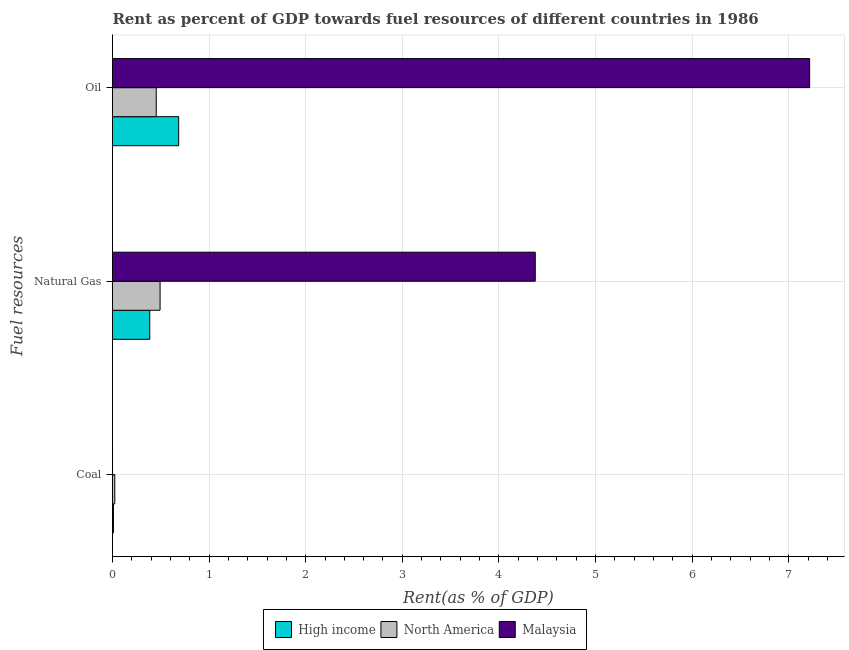How many different coloured bars are there?
Offer a terse response. 3. What is the label of the 1st group of bars from the top?
Offer a terse response. Oil. What is the rent towards oil in High income?
Offer a terse response. 0.68. Across all countries, what is the maximum rent towards natural gas?
Provide a succinct answer. 4.38. Across all countries, what is the minimum rent towards natural gas?
Make the answer very short. 0.39. In which country was the rent towards oil maximum?
Make the answer very short. Malaysia. In which country was the rent towards coal minimum?
Provide a succinct answer. Malaysia. What is the total rent towards natural gas in the graph?
Your answer should be very brief. 5.25. What is the difference between the rent towards natural gas in North America and that in Malaysia?
Ensure brevity in your answer.  -3.88. What is the difference between the rent towards coal in Malaysia and the rent towards oil in High income?
Provide a short and direct response. -0.68. What is the average rent towards coal per country?
Give a very brief answer. 0.01. What is the difference between the rent towards natural gas and rent towards coal in Malaysia?
Make the answer very short. 4.38. What is the ratio of the rent towards oil in High income to that in Malaysia?
Your response must be concise. 0.09. Is the difference between the rent towards coal in North America and High income greater than the difference between the rent towards oil in North America and High income?
Provide a short and direct response. Yes. What is the difference between the highest and the second highest rent towards oil?
Give a very brief answer. 6.53. What is the difference between the highest and the lowest rent towards natural gas?
Your response must be concise. 3.99. In how many countries, is the rent towards natural gas greater than the average rent towards natural gas taken over all countries?
Offer a very short reply. 1. Is the sum of the rent towards coal in Malaysia and High income greater than the maximum rent towards oil across all countries?
Provide a succinct answer. No. What does the 1st bar from the top in Oil represents?
Give a very brief answer. Malaysia. Is it the case that in every country, the sum of the rent towards coal and rent towards natural gas is greater than the rent towards oil?
Give a very brief answer. No. Are all the bars in the graph horizontal?
Provide a succinct answer. Yes. Are the values on the major ticks of X-axis written in scientific E-notation?
Ensure brevity in your answer.  No. Does the graph contain any zero values?
Your answer should be compact. No. Does the graph contain grids?
Keep it short and to the point. Yes. Where does the legend appear in the graph?
Make the answer very short. Bottom center. What is the title of the graph?
Offer a terse response. Rent as percent of GDP towards fuel resources of different countries in 1986. What is the label or title of the X-axis?
Provide a succinct answer. Rent(as % of GDP). What is the label or title of the Y-axis?
Provide a short and direct response. Fuel resources. What is the Rent(as % of GDP) of High income in Coal?
Give a very brief answer. 0.01. What is the Rent(as % of GDP) of North America in Coal?
Your answer should be very brief. 0.02. What is the Rent(as % of GDP) in Malaysia in Coal?
Provide a succinct answer. 0. What is the Rent(as % of GDP) of High income in Natural Gas?
Make the answer very short. 0.39. What is the Rent(as % of GDP) in North America in Natural Gas?
Keep it short and to the point. 0.49. What is the Rent(as % of GDP) in Malaysia in Natural Gas?
Your response must be concise. 4.38. What is the Rent(as % of GDP) in High income in Oil?
Give a very brief answer. 0.68. What is the Rent(as % of GDP) in North America in Oil?
Provide a short and direct response. 0.45. What is the Rent(as % of GDP) in Malaysia in Oil?
Offer a terse response. 7.22. Across all Fuel resources, what is the maximum Rent(as % of GDP) of High income?
Your response must be concise. 0.68. Across all Fuel resources, what is the maximum Rent(as % of GDP) of North America?
Ensure brevity in your answer.  0.49. Across all Fuel resources, what is the maximum Rent(as % of GDP) in Malaysia?
Make the answer very short. 7.22. Across all Fuel resources, what is the minimum Rent(as % of GDP) in High income?
Give a very brief answer. 0.01. Across all Fuel resources, what is the minimum Rent(as % of GDP) of North America?
Keep it short and to the point. 0.02. Across all Fuel resources, what is the minimum Rent(as % of GDP) of Malaysia?
Offer a very short reply. 0. What is the total Rent(as % of GDP) in High income in the graph?
Give a very brief answer. 1.08. What is the total Rent(as % of GDP) of North America in the graph?
Your answer should be very brief. 0.97. What is the total Rent(as % of GDP) in Malaysia in the graph?
Ensure brevity in your answer.  11.59. What is the difference between the Rent(as % of GDP) of High income in Coal and that in Natural Gas?
Offer a terse response. -0.38. What is the difference between the Rent(as % of GDP) of North America in Coal and that in Natural Gas?
Your answer should be very brief. -0.47. What is the difference between the Rent(as % of GDP) of Malaysia in Coal and that in Natural Gas?
Your answer should be very brief. -4.38. What is the difference between the Rent(as % of GDP) in High income in Coal and that in Oil?
Ensure brevity in your answer.  -0.68. What is the difference between the Rent(as % of GDP) of North America in Coal and that in Oil?
Ensure brevity in your answer.  -0.43. What is the difference between the Rent(as % of GDP) in Malaysia in Coal and that in Oil?
Offer a terse response. -7.22. What is the difference between the Rent(as % of GDP) in High income in Natural Gas and that in Oil?
Keep it short and to the point. -0.3. What is the difference between the Rent(as % of GDP) of North America in Natural Gas and that in Oil?
Provide a short and direct response. 0.04. What is the difference between the Rent(as % of GDP) of Malaysia in Natural Gas and that in Oil?
Make the answer very short. -2.84. What is the difference between the Rent(as % of GDP) in High income in Coal and the Rent(as % of GDP) in North America in Natural Gas?
Provide a short and direct response. -0.48. What is the difference between the Rent(as % of GDP) of High income in Coal and the Rent(as % of GDP) of Malaysia in Natural Gas?
Offer a very short reply. -4.37. What is the difference between the Rent(as % of GDP) in North America in Coal and the Rent(as % of GDP) in Malaysia in Natural Gas?
Your answer should be very brief. -4.35. What is the difference between the Rent(as % of GDP) of High income in Coal and the Rent(as % of GDP) of North America in Oil?
Your answer should be very brief. -0.44. What is the difference between the Rent(as % of GDP) of High income in Coal and the Rent(as % of GDP) of Malaysia in Oil?
Your answer should be compact. -7.21. What is the difference between the Rent(as % of GDP) of North America in Coal and the Rent(as % of GDP) of Malaysia in Oil?
Provide a short and direct response. -7.19. What is the difference between the Rent(as % of GDP) in High income in Natural Gas and the Rent(as % of GDP) in North America in Oil?
Provide a succinct answer. -0.07. What is the difference between the Rent(as % of GDP) in High income in Natural Gas and the Rent(as % of GDP) in Malaysia in Oil?
Your answer should be very brief. -6.83. What is the difference between the Rent(as % of GDP) in North America in Natural Gas and the Rent(as % of GDP) in Malaysia in Oil?
Provide a short and direct response. -6.72. What is the average Rent(as % of GDP) in High income per Fuel resources?
Your answer should be very brief. 0.36. What is the average Rent(as % of GDP) in North America per Fuel resources?
Your answer should be very brief. 0.32. What is the average Rent(as % of GDP) in Malaysia per Fuel resources?
Keep it short and to the point. 3.86. What is the difference between the Rent(as % of GDP) of High income and Rent(as % of GDP) of North America in Coal?
Offer a very short reply. -0.01. What is the difference between the Rent(as % of GDP) of High income and Rent(as % of GDP) of Malaysia in Coal?
Keep it short and to the point. 0.01. What is the difference between the Rent(as % of GDP) in North America and Rent(as % of GDP) in Malaysia in Coal?
Ensure brevity in your answer.  0.02. What is the difference between the Rent(as % of GDP) in High income and Rent(as % of GDP) in North America in Natural Gas?
Offer a very short reply. -0.11. What is the difference between the Rent(as % of GDP) in High income and Rent(as % of GDP) in Malaysia in Natural Gas?
Provide a succinct answer. -3.99. What is the difference between the Rent(as % of GDP) of North America and Rent(as % of GDP) of Malaysia in Natural Gas?
Provide a succinct answer. -3.88. What is the difference between the Rent(as % of GDP) of High income and Rent(as % of GDP) of North America in Oil?
Your answer should be very brief. 0.23. What is the difference between the Rent(as % of GDP) in High income and Rent(as % of GDP) in Malaysia in Oil?
Make the answer very short. -6.53. What is the difference between the Rent(as % of GDP) in North America and Rent(as % of GDP) in Malaysia in Oil?
Your answer should be compact. -6.76. What is the ratio of the Rent(as % of GDP) of High income in Coal to that in Natural Gas?
Make the answer very short. 0.03. What is the ratio of the Rent(as % of GDP) in North America in Coal to that in Natural Gas?
Keep it short and to the point. 0.05. What is the ratio of the Rent(as % of GDP) of High income in Coal to that in Oil?
Give a very brief answer. 0.01. What is the ratio of the Rent(as % of GDP) in North America in Coal to that in Oil?
Ensure brevity in your answer.  0.05. What is the ratio of the Rent(as % of GDP) in Malaysia in Coal to that in Oil?
Keep it short and to the point. 0. What is the ratio of the Rent(as % of GDP) in High income in Natural Gas to that in Oil?
Offer a very short reply. 0.56. What is the ratio of the Rent(as % of GDP) in North America in Natural Gas to that in Oil?
Your response must be concise. 1.09. What is the ratio of the Rent(as % of GDP) in Malaysia in Natural Gas to that in Oil?
Your answer should be very brief. 0.61. What is the difference between the highest and the second highest Rent(as % of GDP) of High income?
Your response must be concise. 0.3. What is the difference between the highest and the second highest Rent(as % of GDP) of North America?
Your answer should be very brief. 0.04. What is the difference between the highest and the second highest Rent(as % of GDP) of Malaysia?
Offer a very short reply. 2.84. What is the difference between the highest and the lowest Rent(as % of GDP) of High income?
Your answer should be compact. 0.68. What is the difference between the highest and the lowest Rent(as % of GDP) of North America?
Provide a succinct answer. 0.47. What is the difference between the highest and the lowest Rent(as % of GDP) in Malaysia?
Keep it short and to the point. 7.22. 